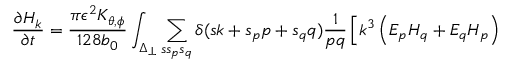Convert formula to latex. <formula><loc_0><loc_0><loc_500><loc_500>\frac { \partial H _ { k } } { \partial t } = \frac { \pi \epsilon ^ { 2 } K _ { \theta , \phi } } { 1 2 8 b _ { 0 } } \int _ { \Delta _ { \perp } } \sum _ { s s _ { p } s _ { q } } \delta ( s k + s _ { p } p + s _ { q } q ) \frac { 1 } { p q } \left [ k ^ { 3 } \left ( E _ { p } H _ { q } + E _ { q } H _ { p } \right )</formula> 